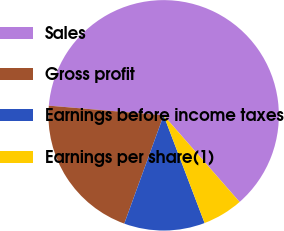<chart> <loc_0><loc_0><loc_500><loc_500><pie_chart><fcel>Sales<fcel>Gross profit<fcel>Earnings before income taxes<fcel>Earnings per share(1)<nl><fcel>62.21%<fcel>20.79%<fcel>11.33%<fcel>5.67%<nl></chart> 